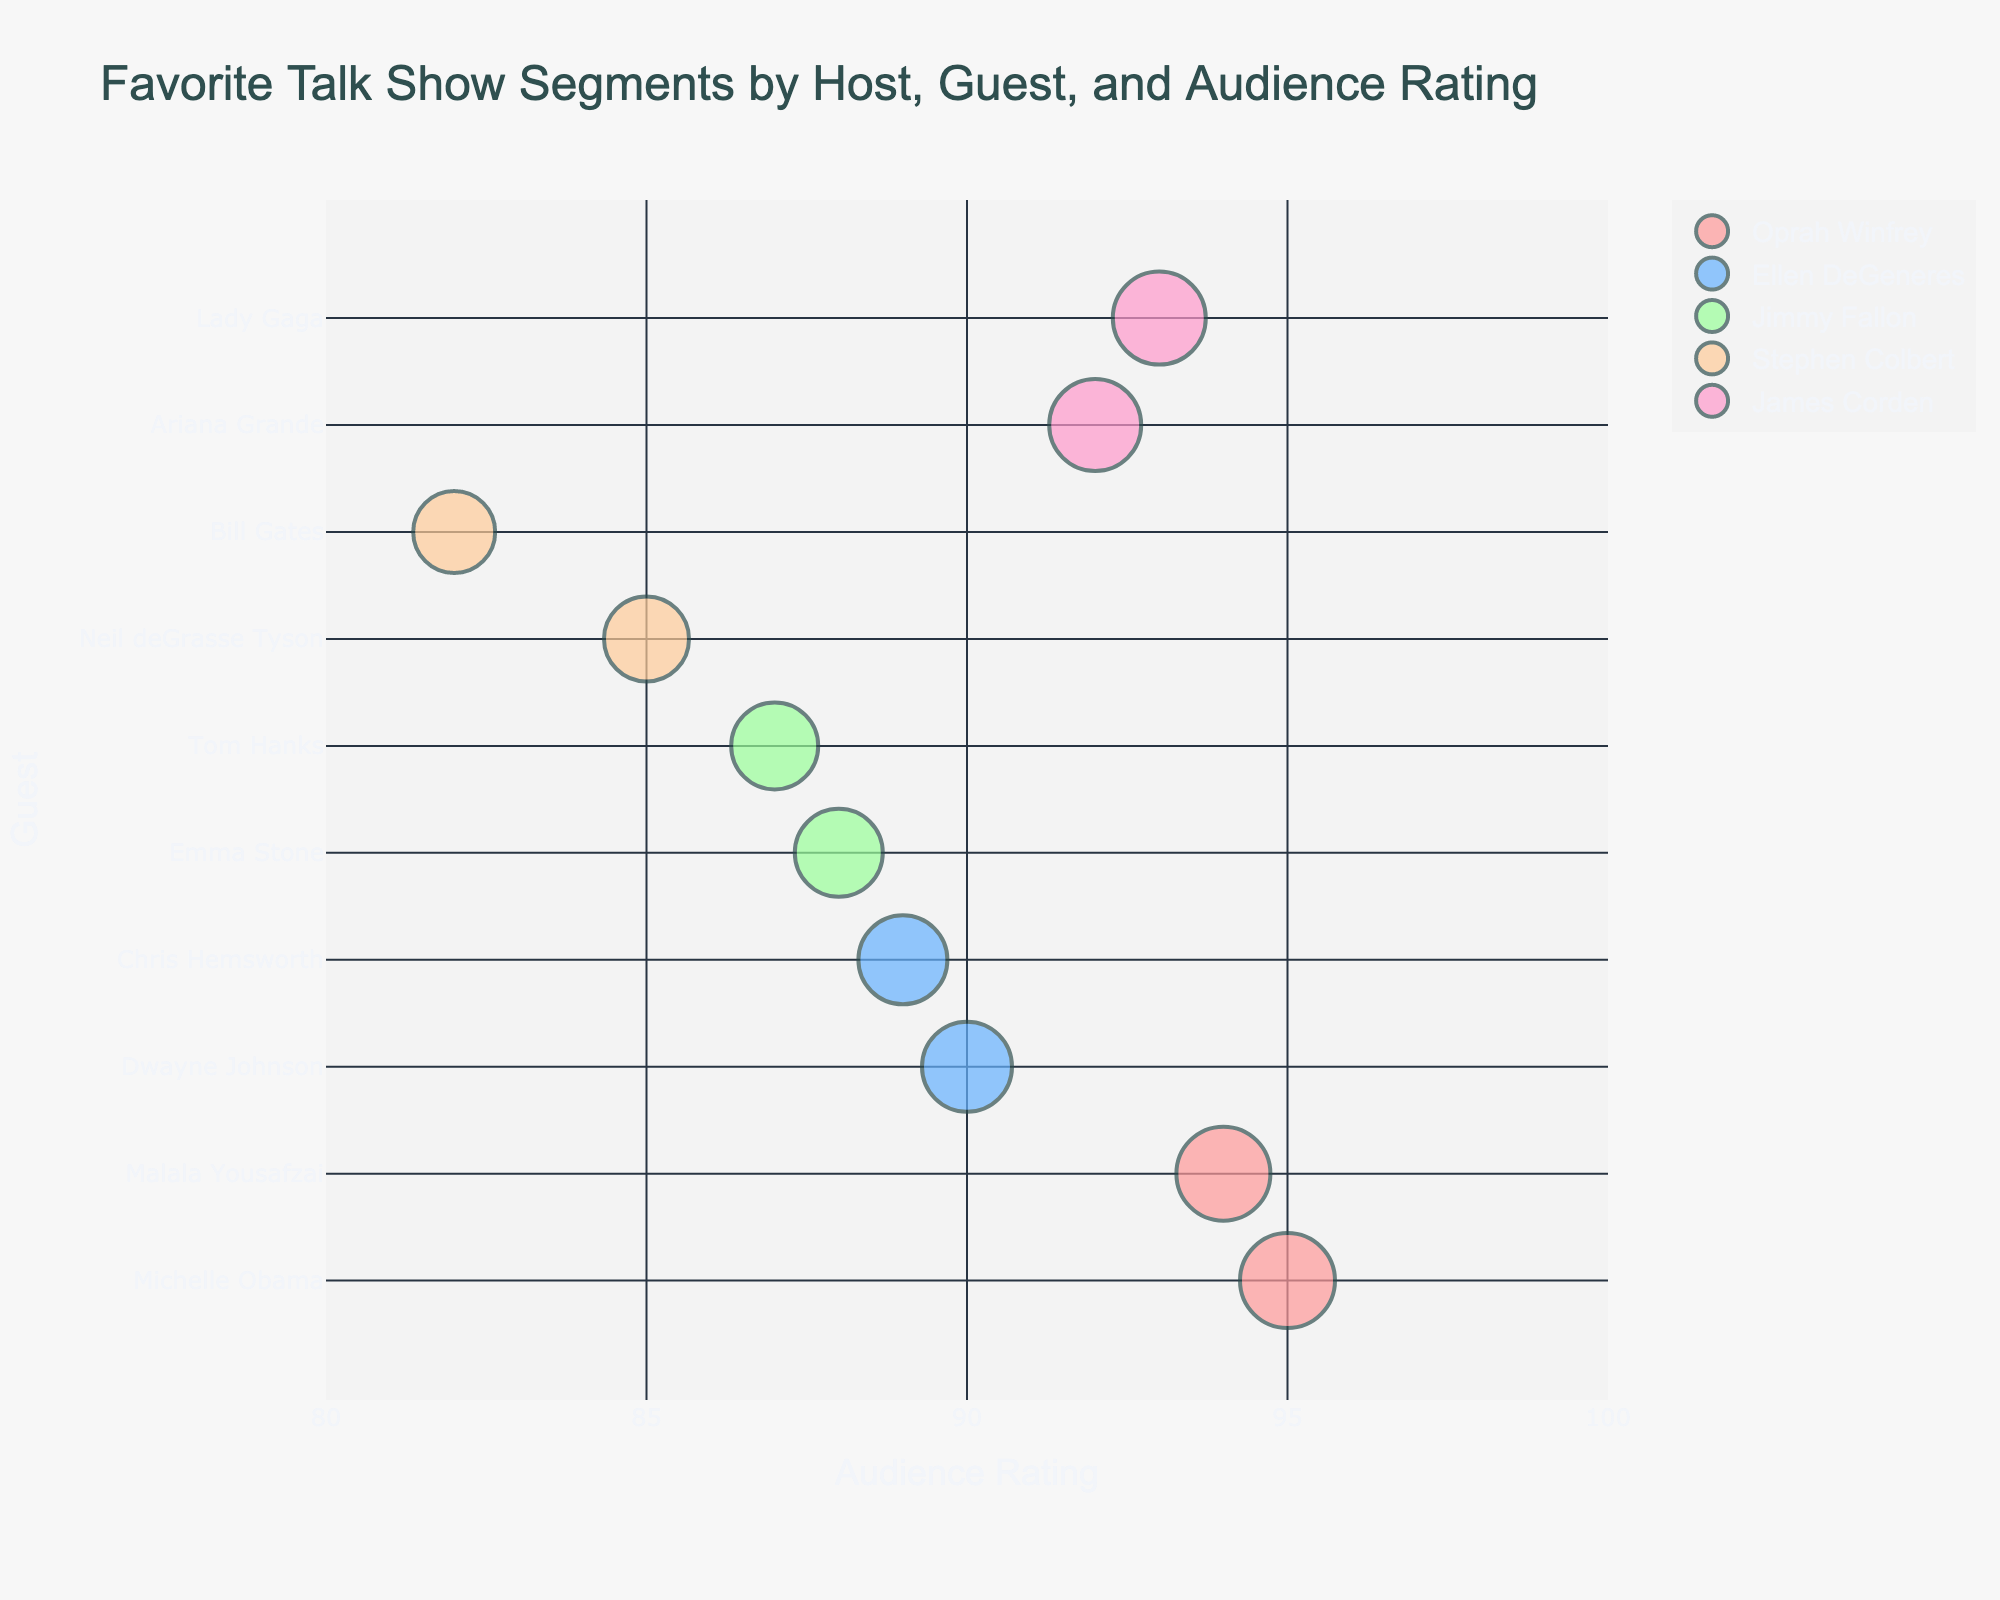Which host has the highest-rated segment? Look for the largest bubble and read the host's name which is associated with the highest rating on the x-axis.
Answer: Oprah Winfrey Who are the guests featured by Oprah Winfrey? Identify the bubbles associated with Oprah Winfrey by their color, then read the guest names near those bubbles.
Answer: Michelle Obama, Malala Yousafzai What is the average audience rating for segments hosted by Ellen DeGeneres? Locate Ellen DeGeneres' bubbles, note the audience ratings, and calculate the average of these ratings. (90 + 89) / 2 = 89.5
Answer: 89.5 Between Jimmy Fallon and James Corden, who has the higher-rated segment on average? Identify the bubbles for both hosts, note down their respective audience ratings, calculate their averages, and compare. (88+87)/2 = 87.5 for Jimmy Fallon, (92+93)/2 = 92.5 for James Corden.
Answer: James Corden Which guest appears in segments hosted by different hosts? Look for guest names that appear near bubbles of different colors (representing different hosts).
Answer: Ariana Grande appears for James Corden Which segment has the lowest audience rating? Find the smallest bubble and read the text information to identify the segment.
Answer: Future of Technology Are segments with higher audience ratings more frequent with a particular host? Compare the characteristics and distribution of bubbles across hosts, focusing on high rating values on the x-axis.
Answer: Oprah Winfrey What is the difference in audience rating between “Inspiring Women” and “Empowering Stories”? Locate the respective bubbles, note their ratings, and calculate the difference (95 - 94).
Answer: 1 Which host has featured more guests? Count the number of unique guests for each host.
Answer: James Corden Does Stephen Colbert have any segments with a rating above 85? Examine the bubbles linked to Stephen Colbert, noting if any have a rating that exceeds 85.
Answer: No 